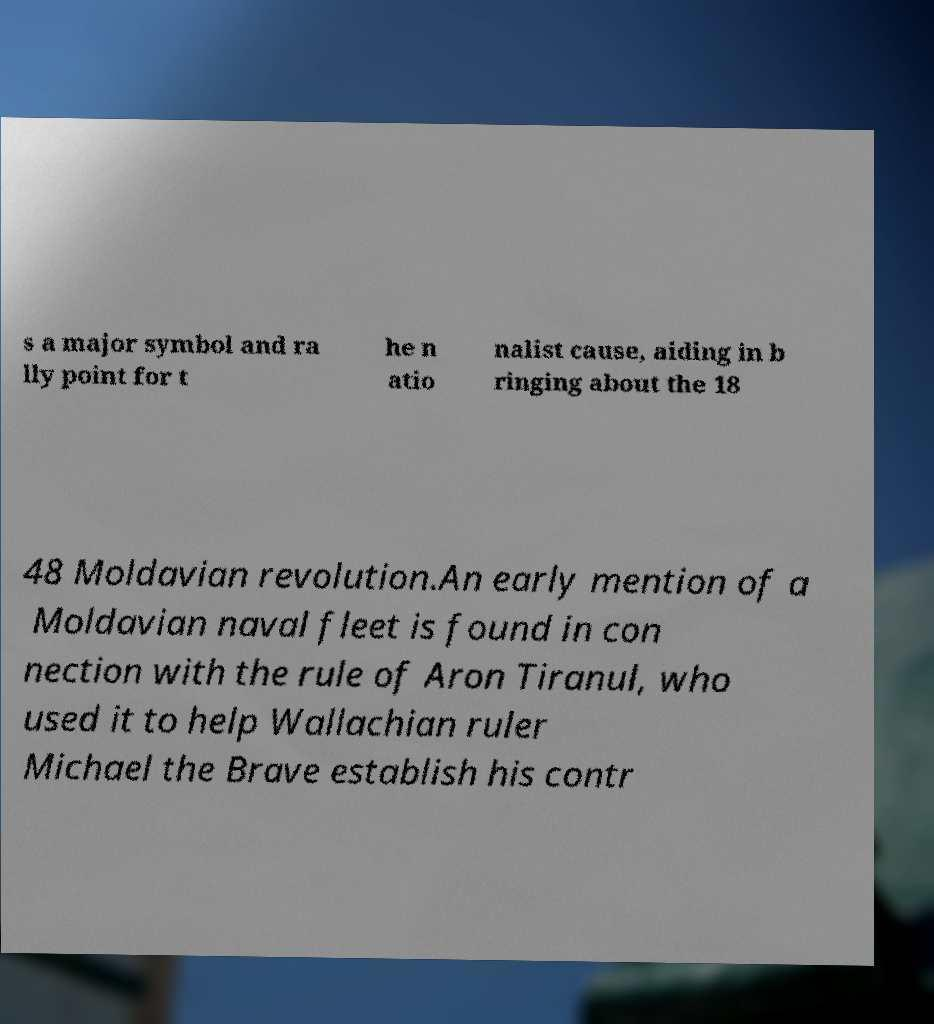What messages or text are displayed in this image? I need them in a readable, typed format. s a major symbol and ra lly point for t he n atio nalist cause, aiding in b ringing about the 18 48 Moldavian revolution.An early mention of a Moldavian naval fleet is found in con nection with the rule of Aron Tiranul, who used it to help Wallachian ruler Michael the Brave establish his contr 